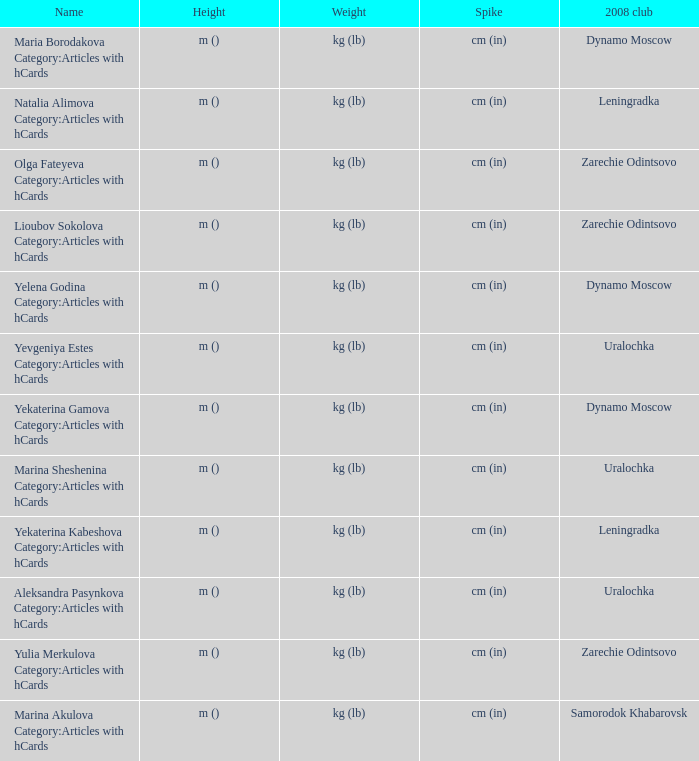What is the name when the 2008 club is zarechie odintsovo? Olga Fateyeva Category:Articles with hCards, Lioubov Sokolova Category:Articles with hCards, Yulia Merkulova Category:Articles with hCards. 